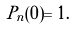Convert formula to latex. <formula><loc_0><loc_0><loc_500><loc_500>P _ { n } ( 0 ) = 1 .</formula> 